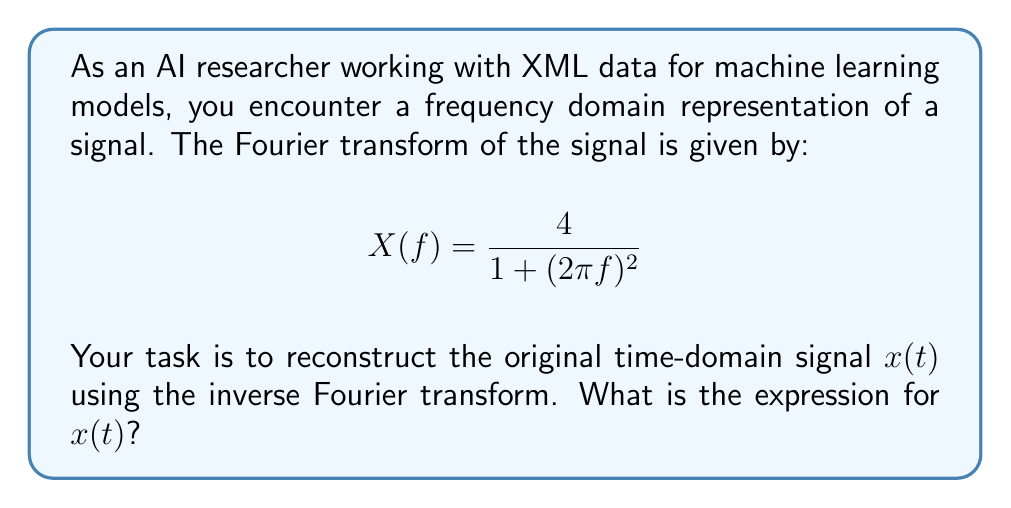Can you answer this question? To solve this problem, we need to apply the inverse Fourier transform to the given frequency domain representation. The process is as follows:

1) The inverse Fourier transform is defined as:

   $$x(t) = \int_{-\infty}^{\infty} X(f) e^{j2\pi ft} df$$

2) Substituting the given $X(f)$ into this equation:

   $$x(t) = \int_{-\infty}^{\infty} \frac{4}{1 + (2\pi f)^2} e^{j2\pi ft} df$$

3) This integral can be solved using complex analysis techniques, specifically the residue theorem. However, we can recognize this as a standard Fourier transform pair.

4) The Fourier transform pair for an exponential decay function is:

   $$\frac{2a}{a^2 + (2\pi f)^2} \leftrightarrow e^{-a|t|}$$

5) Comparing our $X(f)$ with this standard form, we can see that:

   $$\frac{4}{1 + (2\pi f)^2} = \frac{2a}{a^2 + (2\pi f)^2}$$

   where $a = 1$ and the numerator is doubled.

6) Therefore, the corresponding time-domain function will be:

   $$x(t) = 2e^{-|t|}$$

This is the reconstructed time-domain signal from the given frequency domain representation.
Answer: $x(t) = 2e^{-|t|}$ 